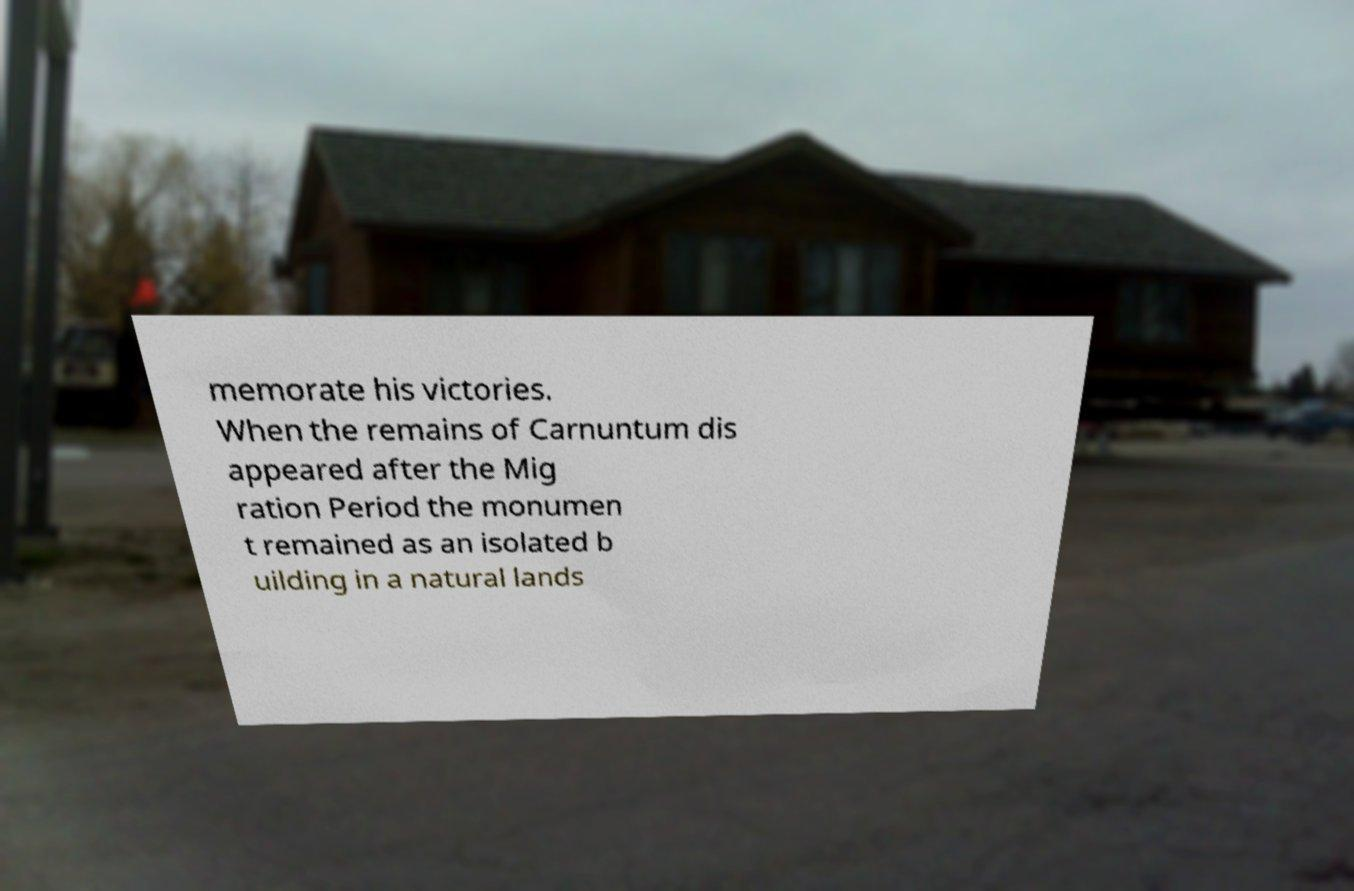What messages or text are displayed in this image? I need them in a readable, typed format. memorate his victories. When the remains of Carnuntum dis appeared after the Mig ration Period the monumen t remained as an isolated b uilding in a natural lands 